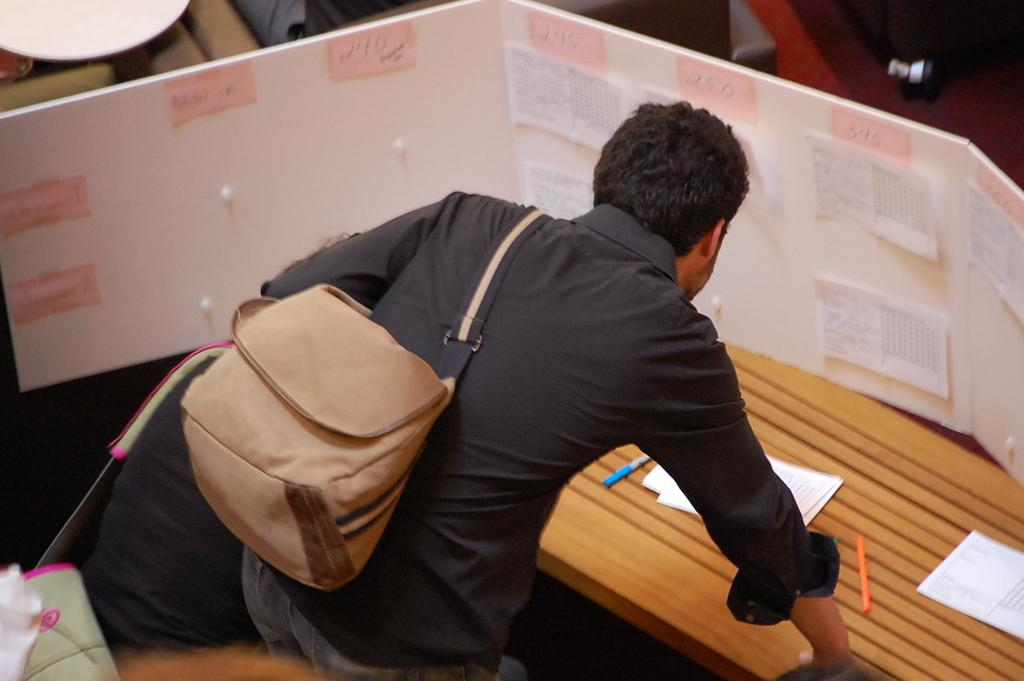What is the main subject of the image? There is a person standing in the image. What is the person wearing in the image? The person is wearing a bag. Where is the person standing in relation to the table? The person is standing in front of a table. What items can be seen on the table? There are pens and paper on the table. How does the person act when they reach the edge of the table in the image? There is no indication in the image that the person reaches the edge of the table or performs any specific action. 